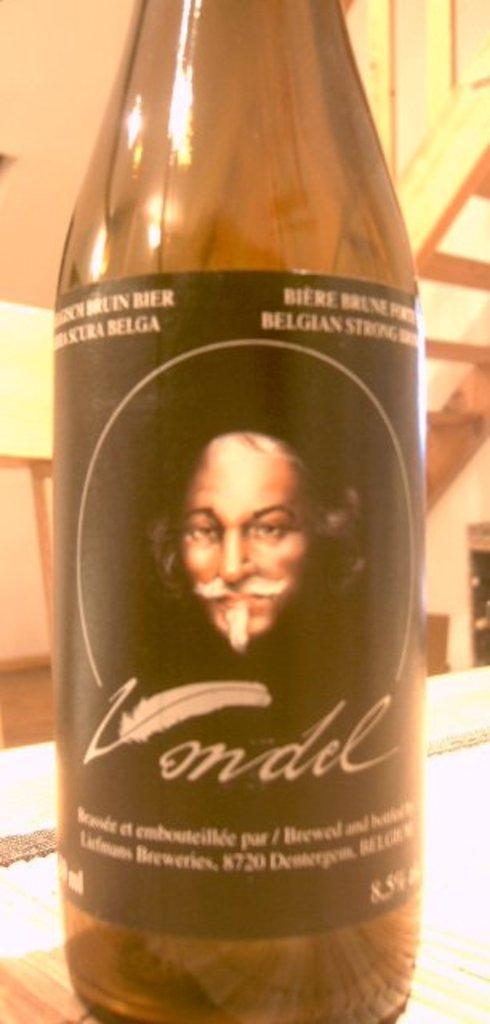What country is this spirit from?
Offer a very short reply. Belgium. 